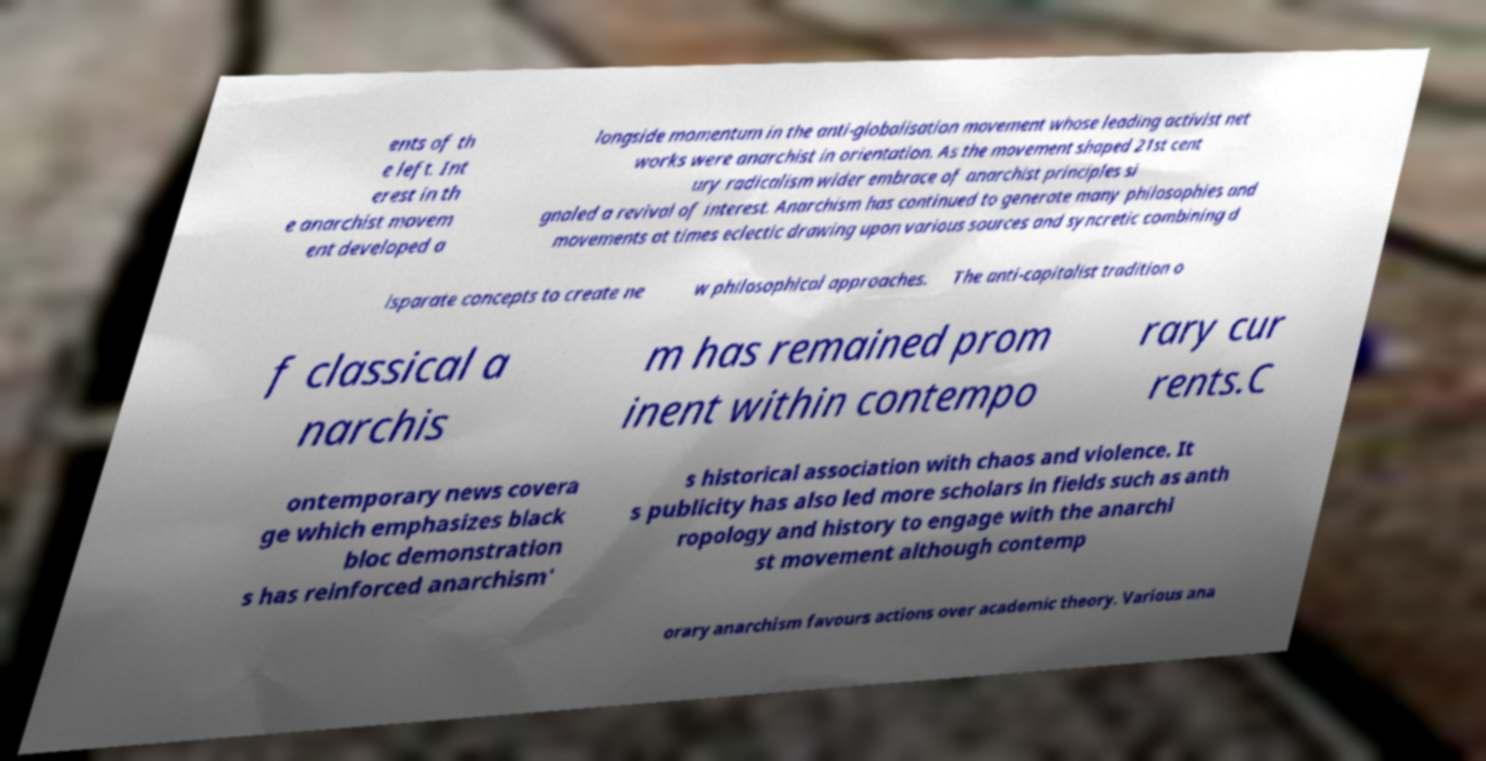Can you accurately transcribe the text from the provided image for me? ents of th e left. Int erest in th e anarchist movem ent developed a longside momentum in the anti-globalisation movement whose leading activist net works were anarchist in orientation. As the movement shaped 21st cent ury radicalism wider embrace of anarchist principles si gnaled a revival of interest. Anarchism has continued to generate many philosophies and movements at times eclectic drawing upon various sources and syncretic combining d isparate concepts to create ne w philosophical approaches. The anti-capitalist tradition o f classical a narchis m has remained prom inent within contempo rary cur rents.C ontemporary news covera ge which emphasizes black bloc demonstration s has reinforced anarchism' s historical association with chaos and violence. It s publicity has also led more scholars in fields such as anth ropology and history to engage with the anarchi st movement although contemp orary anarchism favours actions over academic theory. Various ana 